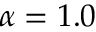Convert formula to latex. <formula><loc_0><loc_0><loc_500><loc_500>\alpha = 1 . 0</formula> 